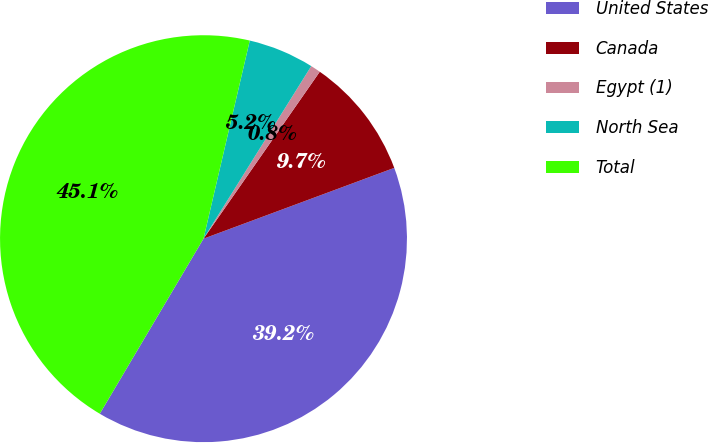<chart> <loc_0><loc_0><loc_500><loc_500><pie_chart><fcel>United States<fcel>Canada<fcel>Egypt (1)<fcel>North Sea<fcel>Total<nl><fcel>39.17%<fcel>9.66%<fcel>0.8%<fcel>5.23%<fcel>45.14%<nl></chart> 